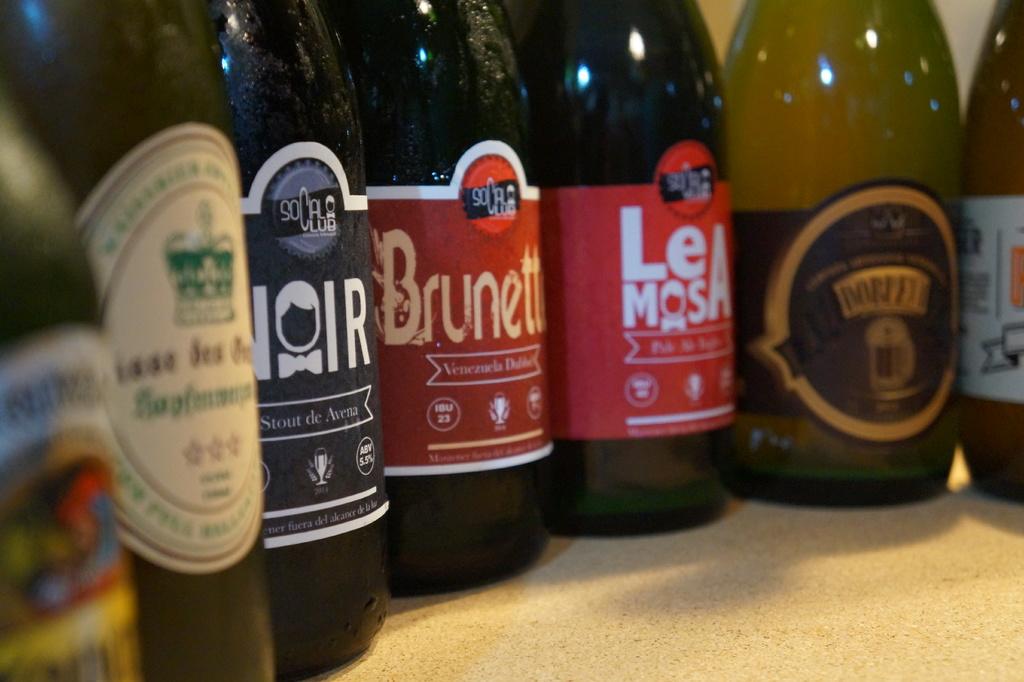What brand are the three middle bottles?
Make the answer very short. Socal club. 